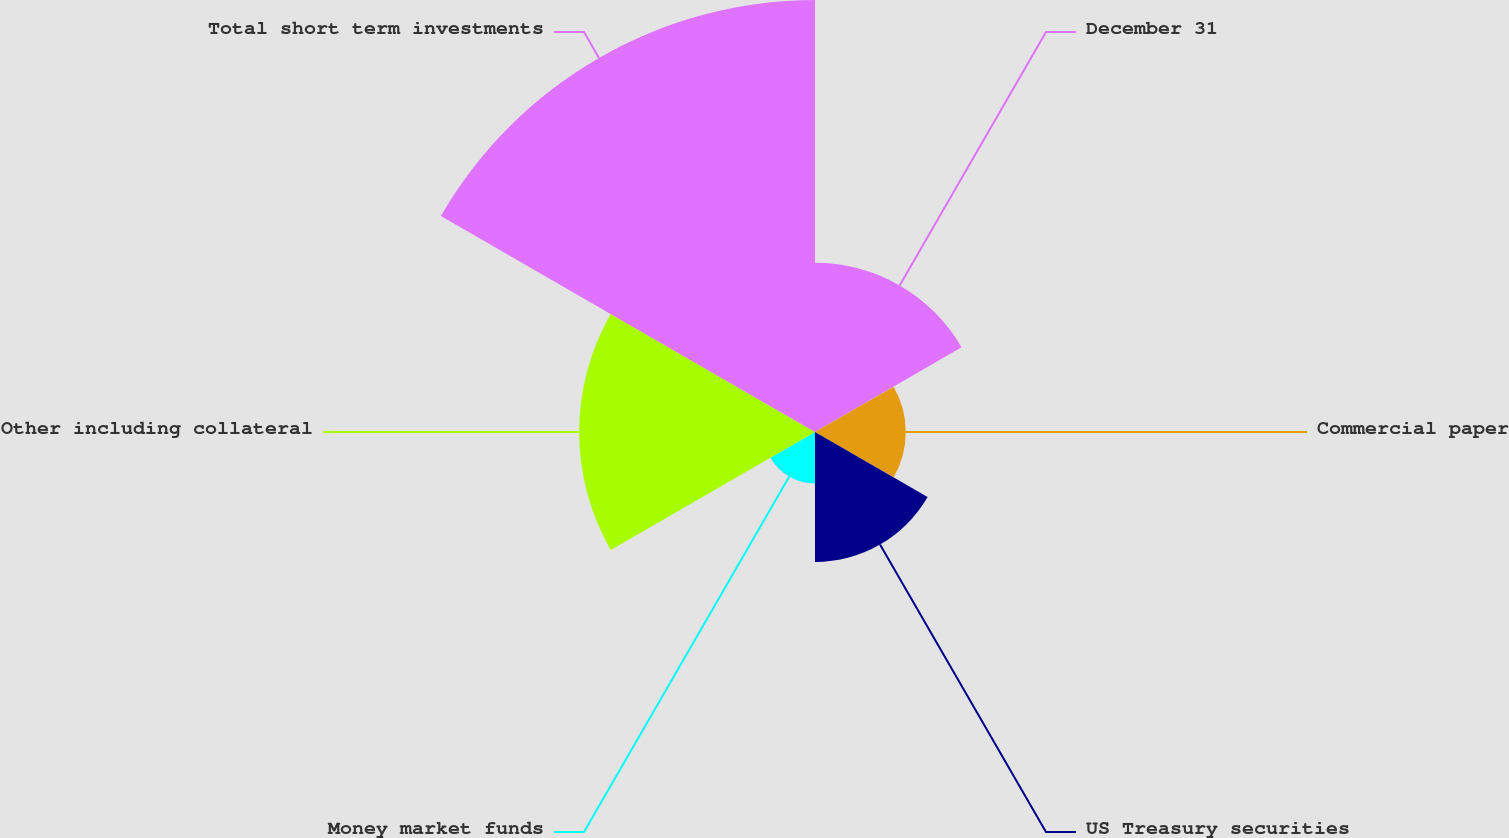Convert chart. <chart><loc_0><loc_0><loc_500><loc_500><pie_chart><fcel>December 31<fcel>Commercial paper<fcel>US Treasury securities<fcel>Money market funds<fcel>Other including collateral<fcel>Total short term investments<nl><fcel>15.26%<fcel>8.18%<fcel>11.72%<fcel>4.64%<fcel>21.26%<fcel>38.94%<nl></chart> 